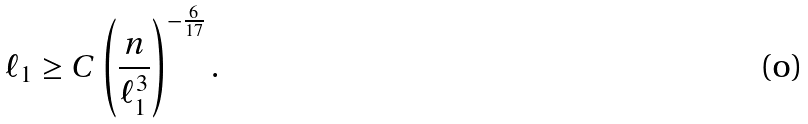<formula> <loc_0><loc_0><loc_500><loc_500>\ell _ { 1 } \geq C \left ( \frac { n } { \ell _ { 1 } ^ { 3 } } \right ) ^ { - \frac { 6 } { 1 7 } } .</formula> 